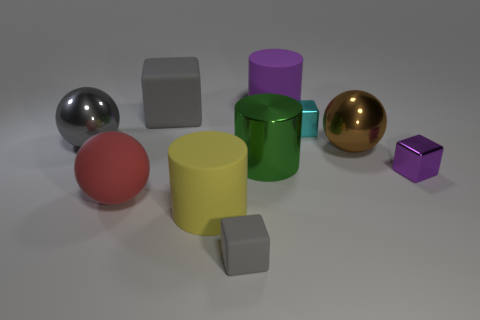There is a purple object in front of the purple rubber cylinder; what is its size?
Keep it short and to the point. Small. What is the size of the metal object that is the same color as the large matte cube?
Ensure brevity in your answer.  Large. Are there any other cylinders that have the same material as the purple cylinder?
Your response must be concise. Yes. Does the large yellow cylinder have the same material as the large purple object?
Your answer should be compact. Yes. There is a shiny cylinder that is the same size as the red sphere; what is its color?
Provide a succinct answer. Green. What number of other things are the same shape as the large green object?
Give a very brief answer. 2. Do the red object and the gray matte object that is on the right side of the yellow matte object have the same size?
Give a very brief answer. No. What number of things are big blue cylinders or cylinders?
Ensure brevity in your answer.  3. How many other objects are the same size as the purple cylinder?
Your response must be concise. 6. Do the big cube and the shiny sphere to the left of the tiny matte thing have the same color?
Make the answer very short. Yes. 